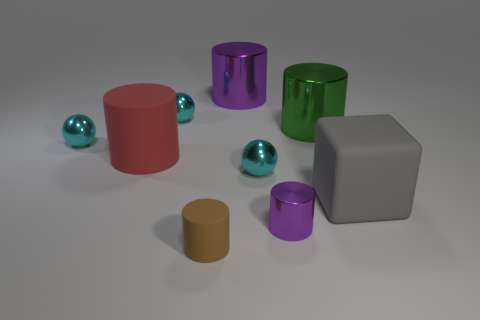Subtract 1 cylinders. How many cylinders are left? 4 Subtract all brown cylinders. How many cylinders are left? 4 Subtract all small brown matte cylinders. How many cylinders are left? 4 Subtract all gray cylinders. Subtract all yellow balls. How many cylinders are left? 5 Subtract all blocks. How many objects are left? 8 Add 3 big red objects. How many big red objects exist? 4 Subtract 0 blue cylinders. How many objects are left? 9 Subtract all big red cylinders. Subtract all matte cylinders. How many objects are left? 6 Add 8 small rubber things. How many small rubber things are left? 9 